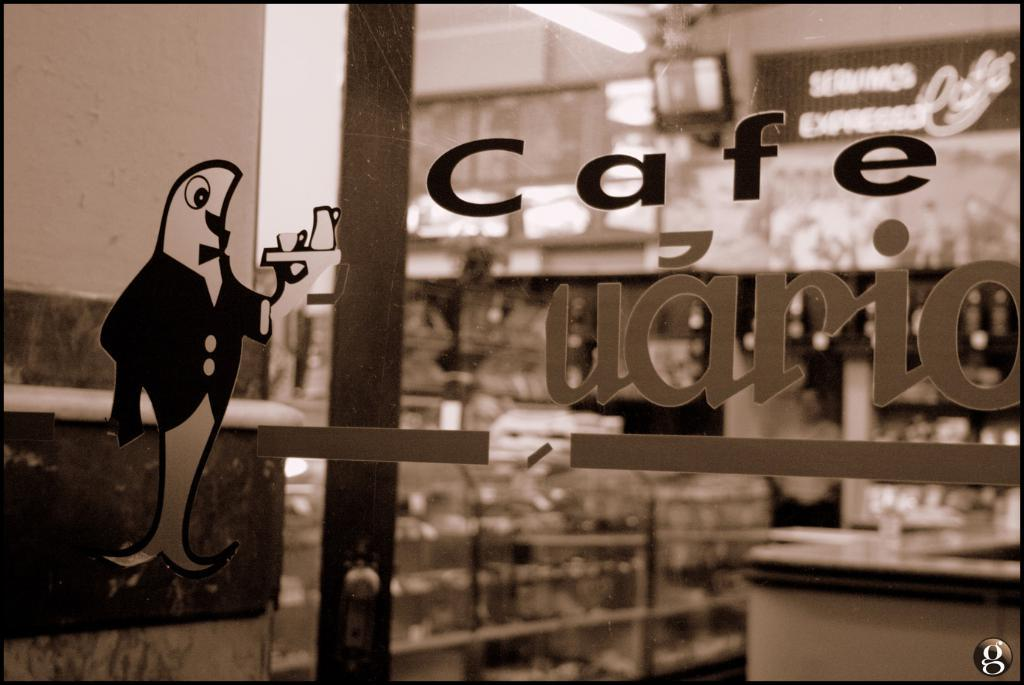What type of image is present in the picture? There is a cartoon image in the picture. What additional feature can be seen on the cartoon image? There is text written on the cartoon image. How would you describe the background of the image? The background of the image is blurred. How many ladybugs can be seen crawling on the cartoon image? There are no ladybugs present on the cartoon image in the picture. What type of honey is being used to write the text on the cartoon image? There is no honey present on the cartoon image in the picture. 